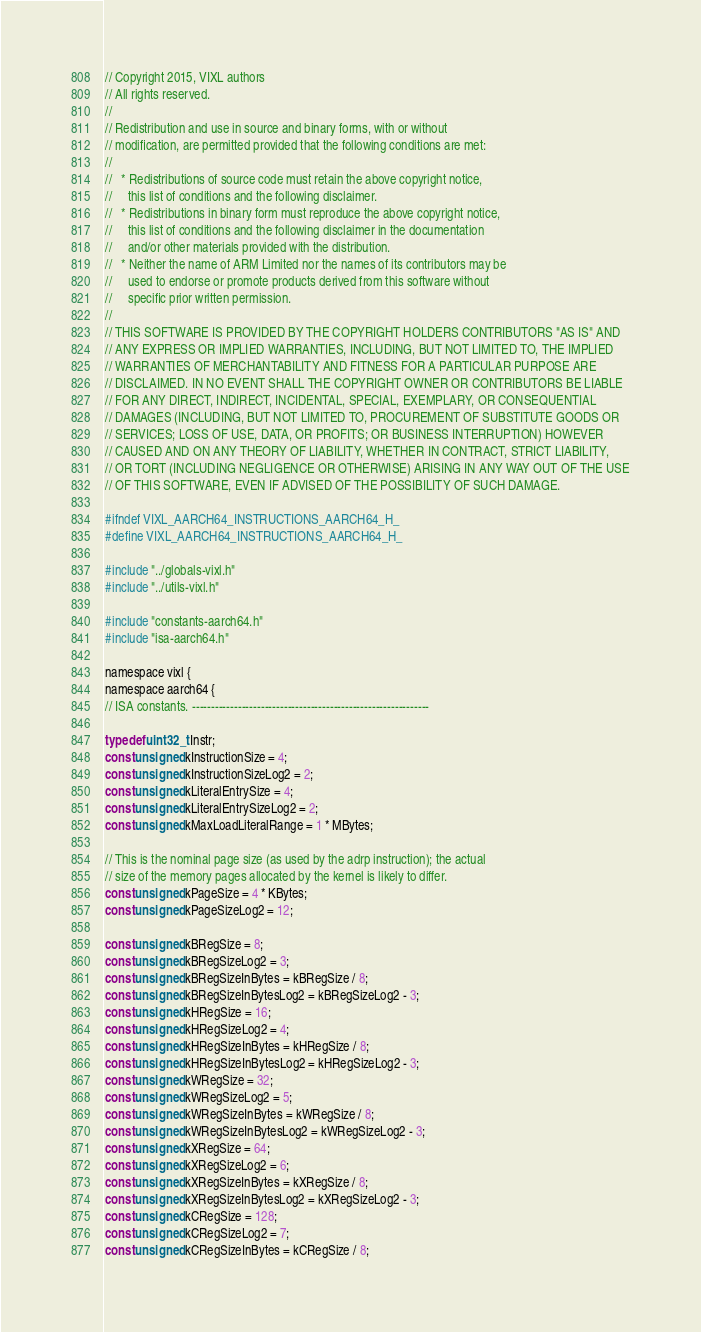Convert code to text. <code><loc_0><loc_0><loc_500><loc_500><_C_>// Copyright 2015, VIXL authors
// All rights reserved.
//
// Redistribution and use in source and binary forms, with or without
// modification, are permitted provided that the following conditions are met:
//
//   * Redistributions of source code must retain the above copyright notice,
//     this list of conditions and the following disclaimer.
//   * Redistributions in binary form must reproduce the above copyright notice,
//     this list of conditions and the following disclaimer in the documentation
//     and/or other materials provided with the distribution.
//   * Neither the name of ARM Limited nor the names of its contributors may be
//     used to endorse or promote products derived from this software without
//     specific prior written permission.
//
// THIS SOFTWARE IS PROVIDED BY THE COPYRIGHT HOLDERS CONTRIBUTORS "AS IS" AND
// ANY EXPRESS OR IMPLIED WARRANTIES, INCLUDING, BUT NOT LIMITED TO, THE IMPLIED
// WARRANTIES OF MERCHANTABILITY AND FITNESS FOR A PARTICULAR PURPOSE ARE
// DISCLAIMED. IN NO EVENT SHALL THE COPYRIGHT OWNER OR CONTRIBUTORS BE LIABLE
// FOR ANY DIRECT, INDIRECT, INCIDENTAL, SPECIAL, EXEMPLARY, OR CONSEQUENTIAL
// DAMAGES (INCLUDING, BUT NOT LIMITED TO, PROCUREMENT OF SUBSTITUTE GOODS OR
// SERVICES; LOSS OF USE, DATA, OR PROFITS; OR BUSINESS INTERRUPTION) HOWEVER
// CAUSED AND ON ANY THEORY OF LIABILITY, WHETHER IN CONTRACT, STRICT LIABILITY,
// OR TORT (INCLUDING NEGLIGENCE OR OTHERWISE) ARISING IN ANY WAY OUT OF THE USE
// OF THIS SOFTWARE, EVEN IF ADVISED OF THE POSSIBILITY OF SUCH DAMAGE.

#ifndef VIXL_AARCH64_INSTRUCTIONS_AARCH64_H_
#define VIXL_AARCH64_INSTRUCTIONS_AARCH64_H_

#include "../globals-vixl.h"
#include "../utils-vixl.h"

#include "constants-aarch64.h"
#include "isa-aarch64.h"

namespace vixl {
namespace aarch64 {
// ISA constants. --------------------------------------------------------------

typedef uint32_t Instr;
const unsigned kInstructionSize = 4;
const unsigned kInstructionSizeLog2 = 2;
const unsigned kLiteralEntrySize = 4;
const unsigned kLiteralEntrySizeLog2 = 2;
const unsigned kMaxLoadLiteralRange = 1 * MBytes;

// This is the nominal page size (as used by the adrp instruction); the actual
// size of the memory pages allocated by the kernel is likely to differ.
const unsigned kPageSize = 4 * KBytes;
const unsigned kPageSizeLog2 = 12;

const unsigned kBRegSize = 8;
const unsigned kBRegSizeLog2 = 3;
const unsigned kBRegSizeInBytes = kBRegSize / 8;
const unsigned kBRegSizeInBytesLog2 = kBRegSizeLog2 - 3;
const unsigned kHRegSize = 16;
const unsigned kHRegSizeLog2 = 4;
const unsigned kHRegSizeInBytes = kHRegSize / 8;
const unsigned kHRegSizeInBytesLog2 = kHRegSizeLog2 - 3;
const unsigned kWRegSize = 32;
const unsigned kWRegSizeLog2 = 5;
const unsigned kWRegSizeInBytes = kWRegSize / 8;
const unsigned kWRegSizeInBytesLog2 = kWRegSizeLog2 - 3;
const unsigned kXRegSize = 64;
const unsigned kXRegSizeLog2 = 6;
const unsigned kXRegSizeInBytes = kXRegSize / 8;
const unsigned kXRegSizeInBytesLog2 = kXRegSizeLog2 - 3;
const unsigned kCRegSize = 128;
const unsigned kCRegSizeLog2 = 7;
const unsigned kCRegSizeInBytes = kCRegSize / 8;</code> 